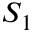<formula> <loc_0><loc_0><loc_500><loc_500>S _ { 1 }</formula> 